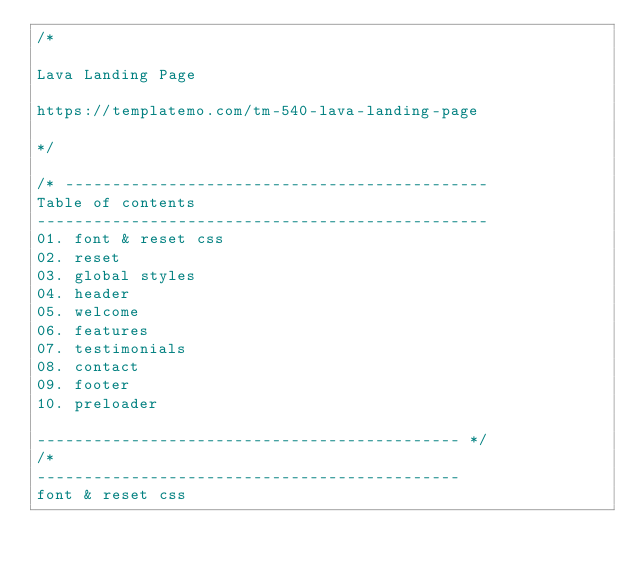Convert code to text. <code><loc_0><loc_0><loc_500><loc_500><_CSS_>/*

Lava Landing Page

https://templatemo.com/tm-540-lava-landing-page

*/

/* ---------------------------------------------
Table of contents
------------------------------------------------
01. font & reset css
02. reset
03. global styles
04. header
05. welcome
06. features
07. testimonials
08. contact
09. footer
10. preloader

--------------------------------------------- */
/* 
---------------------------------------------
font & reset css</code> 